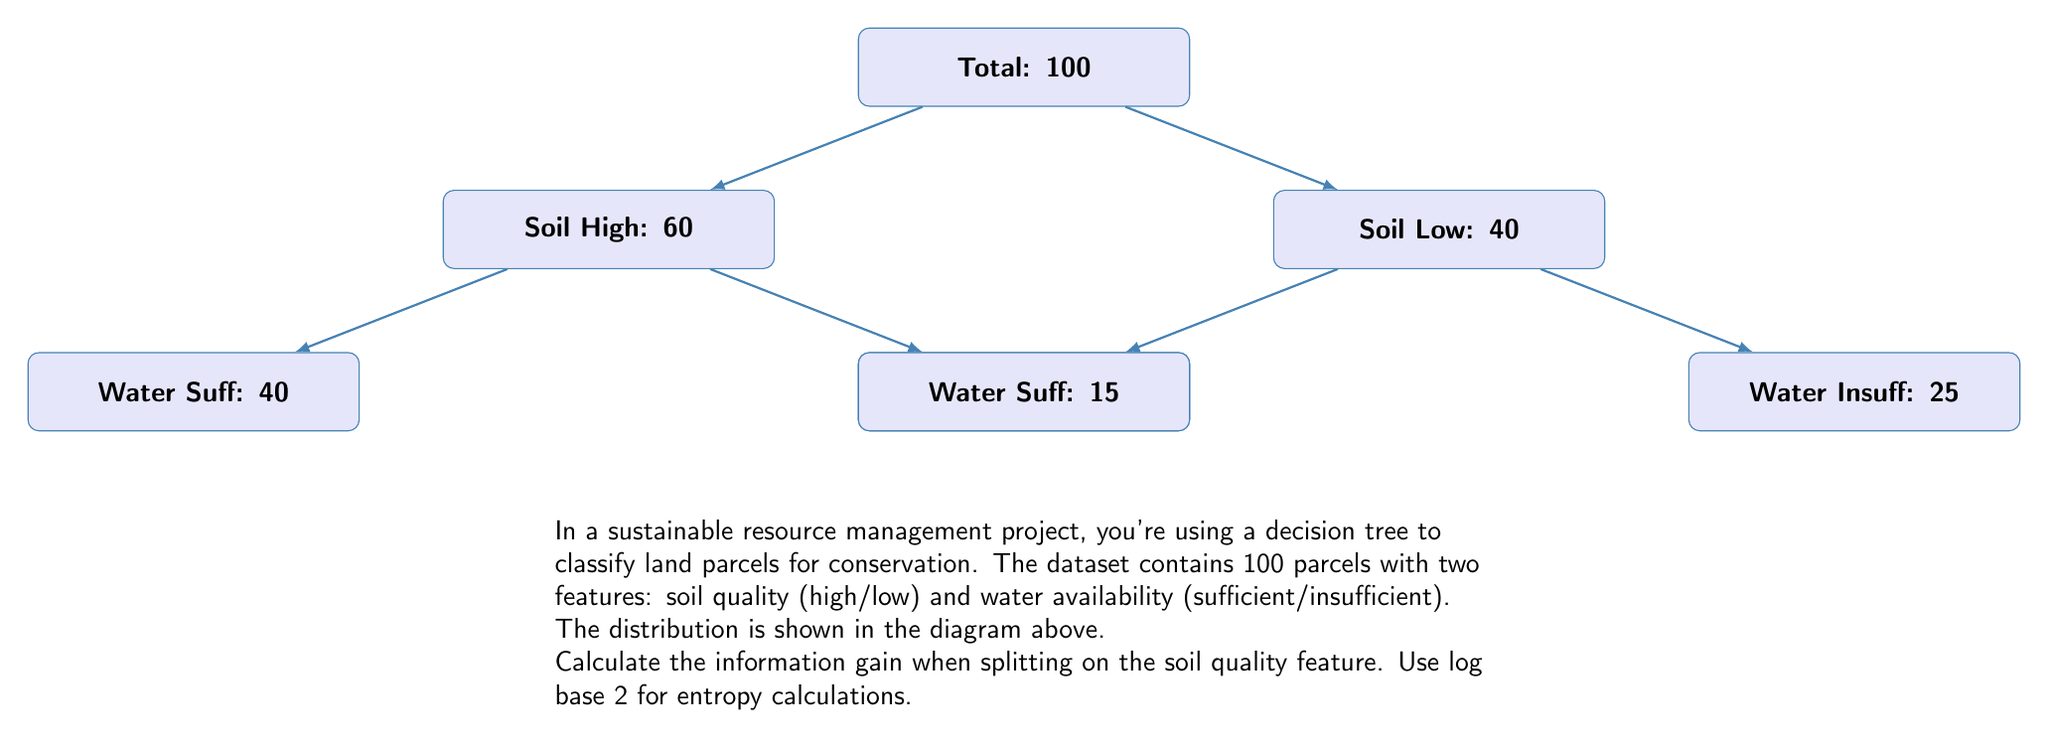What is the answer to this math problem? To calculate the information gain, we need to follow these steps:

1. Calculate the entropy of the entire dataset (parent node).
2. Calculate the entropy of each child node after splitting on soil quality.
3. Calculate the weighted average entropy of the child nodes.
4. Subtract the weighted average entropy from the parent entropy to get the information gain.

Step 1: Entropy of the parent node
Let's consider "Water Sufficient" as the positive class.
$$H(S) = -p_{pos} \log_2(p_{pos}) - p_{neg} \log_2(p_{neg})$$
$$H(S) = -\frac{55}{100} \log_2(\frac{55}{100}) - \frac{45}{100} \log_2(\frac{45}{100}) \approx 0.9928$$

Step 2: Entropy of child nodes
For high soil quality:
$$H(S_{high}) = -\frac{40}{60} \log_2(\frac{40}{60}) - \frac{20}{60} \log_2(\frac{20}{60}) \approx 0.9183$$

For low soil quality:
$$H(S_{low}) = -\frac{15}{40} \log_2(\frac{15}{40}) - \frac{25}{40} \log_2(\frac{25}{40}) \approx 0.9544$$

Step 3: Weighted average entropy of child nodes
$$H_{avg} = \frac{60}{100} * 0.9183 + \frac{40}{100} * 0.9544 \approx 0.9328$$

Step 4: Information gain
$$IG = H(S) - H_{avg} = 0.9928 - 0.9328 = 0.0600$$

Therefore, the information gain when splitting on the soil quality feature is approximately 0.0600 bits.
Answer: 0.0600 bits 